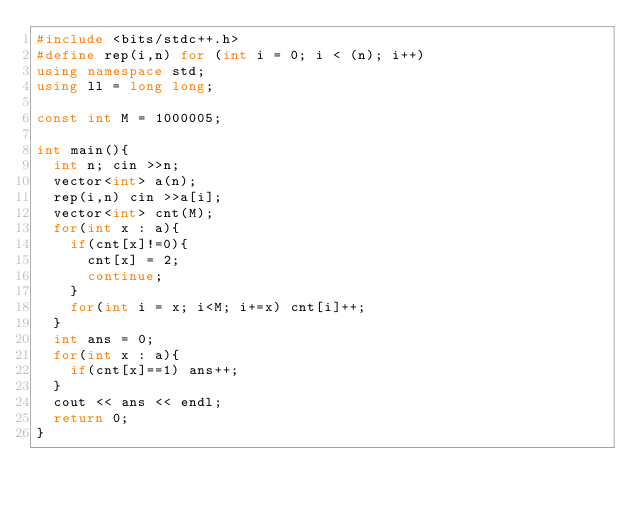Convert code to text. <code><loc_0><loc_0><loc_500><loc_500><_C++_>#include <bits/stdc++.h>
#define rep(i,n) for (int i = 0; i < (n); i++)
using namespace std;
using ll = long long;

const int M = 1000005;

int main(){
  int n; cin >>n;
  vector<int> a(n);
  rep(i,n) cin >>a[i];
  vector<int> cnt(M);
  for(int x : a){
    if(cnt[x]!=0){
      cnt[x] = 2;
      continue;
    }
    for(int i = x; i<M; i+=x) cnt[i]++;
  }
  int ans = 0;
  for(int x : a){
    if(cnt[x]==1) ans++;
  }
  cout << ans << endl;
  return 0; 
}
</code> 